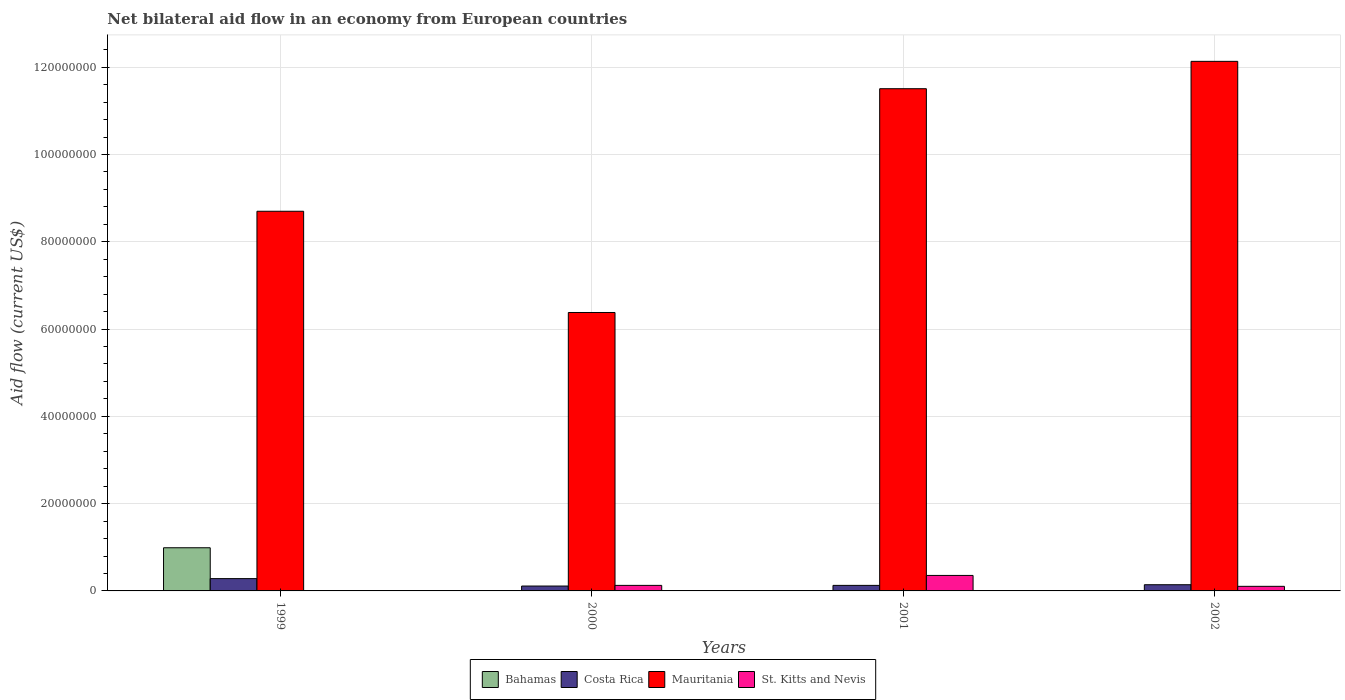How many groups of bars are there?
Make the answer very short. 4. Are the number of bars per tick equal to the number of legend labels?
Keep it short and to the point. No. How many bars are there on the 4th tick from the right?
Give a very brief answer. 3. What is the label of the 3rd group of bars from the left?
Your answer should be very brief. 2001. In how many cases, is the number of bars for a given year not equal to the number of legend labels?
Offer a terse response. 4. What is the net bilateral aid flow in St. Kitts and Nevis in 1999?
Keep it short and to the point. 0. Across all years, what is the maximum net bilateral aid flow in Costa Rica?
Keep it short and to the point. 2.82e+06. In which year was the net bilateral aid flow in Mauritania maximum?
Make the answer very short. 2002. What is the total net bilateral aid flow in Costa Rica in the graph?
Make the answer very short. 6.63e+06. What is the difference between the net bilateral aid flow in Costa Rica in 1999 and that in 2000?
Provide a succinct answer. 1.70e+06. What is the difference between the net bilateral aid flow in St. Kitts and Nevis in 2001 and the net bilateral aid flow in Costa Rica in 1999?
Provide a short and direct response. 7.30e+05. What is the average net bilateral aid flow in Mauritania per year?
Ensure brevity in your answer.  9.68e+07. In the year 1999, what is the difference between the net bilateral aid flow in Costa Rica and net bilateral aid flow in Bahamas?
Offer a very short reply. -7.07e+06. In how many years, is the net bilateral aid flow in Mauritania greater than 44000000 US$?
Provide a succinct answer. 4. What is the ratio of the net bilateral aid flow in Mauritania in 2000 to that in 2002?
Offer a terse response. 0.53. Is the net bilateral aid flow in Mauritania in 1999 less than that in 2002?
Give a very brief answer. Yes. What is the difference between the highest and the second highest net bilateral aid flow in Mauritania?
Offer a very short reply. 6.27e+06. What is the difference between the highest and the lowest net bilateral aid flow in Mauritania?
Provide a short and direct response. 5.76e+07. In how many years, is the net bilateral aid flow in St. Kitts and Nevis greater than the average net bilateral aid flow in St. Kitts and Nevis taken over all years?
Provide a succinct answer. 1. How many years are there in the graph?
Provide a succinct answer. 4. What is the difference between two consecutive major ticks on the Y-axis?
Your answer should be very brief. 2.00e+07. Are the values on the major ticks of Y-axis written in scientific E-notation?
Make the answer very short. No. Does the graph contain grids?
Your answer should be very brief. Yes. Where does the legend appear in the graph?
Keep it short and to the point. Bottom center. How are the legend labels stacked?
Provide a succinct answer. Horizontal. What is the title of the graph?
Keep it short and to the point. Net bilateral aid flow in an economy from European countries. What is the label or title of the Y-axis?
Offer a terse response. Aid flow (current US$). What is the Aid flow (current US$) of Bahamas in 1999?
Keep it short and to the point. 9.89e+06. What is the Aid flow (current US$) in Costa Rica in 1999?
Provide a succinct answer. 2.82e+06. What is the Aid flow (current US$) of Mauritania in 1999?
Keep it short and to the point. 8.70e+07. What is the Aid flow (current US$) in St. Kitts and Nevis in 1999?
Provide a succinct answer. 0. What is the Aid flow (current US$) of Costa Rica in 2000?
Keep it short and to the point. 1.12e+06. What is the Aid flow (current US$) in Mauritania in 2000?
Give a very brief answer. 6.38e+07. What is the Aid flow (current US$) of St. Kitts and Nevis in 2000?
Your answer should be very brief. 1.27e+06. What is the Aid flow (current US$) of Costa Rica in 2001?
Give a very brief answer. 1.27e+06. What is the Aid flow (current US$) in Mauritania in 2001?
Make the answer very short. 1.15e+08. What is the Aid flow (current US$) of St. Kitts and Nevis in 2001?
Provide a succinct answer. 3.55e+06. What is the Aid flow (current US$) of Bahamas in 2002?
Make the answer very short. 0. What is the Aid flow (current US$) in Costa Rica in 2002?
Provide a succinct answer. 1.42e+06. What is the Aid flow (current US$) of Mauritania in 2002?
Keep it short and to the point. 1.21e+08. What is the Aid flow (current US$) in St. Kitts and Nevis in 2002?
Your response must be concise. 1.05e+06. Across all years, what is the maximum Aid flow (current US$) of Bahamas?
Your answer should be compact. 9.89e+06. Across all years, what is the maximum Aid flow (current US$) in Costa Rica?
Offer a very short reply. 2.82e+06. Across all years, what is the maximum Aid flow (current US$) in Mauritania?
Provide a succinct answer. 1.21e+08. Across all years, what is the maximum Aid flow (current US$) in St. Kitts and Nevis?
Your answer should be compact. 3.55e+06. Across all years, what is the minimum Aid flow (current US$) in Bahamas?
Offer a terse response. 0. Across all years, what is the minimum Aid flow (current US$) in Costa Rica?
Give a very brief answer. 1.12e+06. Across all years, what is the minimum Aid flow (current US$) in Mauritania?
Keep it short and to the point. 6.38e+07. Across all years, what is the minimum Aid flow (current US$) of St. Kitts and Nevis?
Offer a very short reply. 0. What is the total Aid flow (current US$) in Bahamas in the graph?
Provide a short and direct response. 9.89e+06. What is the total Aid flow (current US$) in Costa Rica in the graph?
Ensure brevity in your answer.  6.63e+06. What is the total Aid flow (current US$) of Mauritania in the graph?
Keep it short and to the point. 3.87e+08. What is the total Aid flow (current US$) in St. Kitts and Nevis in the graph?
Offer a terse response. 5.87e+06. What is the difference between the Aid flow (current US$) of Costa Rica in 1999 and that in 2000?
Make the answer very short. 1.70e+06. What is the difference between the Aid flow (current US$) of Mauritania in 1999 and that in 2000?
Provide a succinct answer. 2.32e+07. What is the difference between the Aid flow (current US$) of Costa Rica in 1999 and that in 2001?
Ensure brevity in your answer.  1.55e+06. What is the difference between the Aid flow (current US$) in Mauritania in 1999 and that in 2001?
Make the answer very short. -2.81e+07. What is the difference between the Aid flow (current US$) of Costa Rica in 1999 and that in 2002?
Provide a succinct answer. 1.40e+06. What is the difference between the Aid flow (current US$) of Mauritania in 1999 and that in 2002?
Your answer should be very brief. -3.44e+07. What is the difference between the Aid flow (current US$) of Mauritania in 2000 and that in 2001?
Your answer should be very brief. -5.13e+07. What is the difference between the Aid flow (current US$) of St. Kitts and Nevis in 2000 and that in 2001?
Provide a short and direct response. -2.28e+06. What is the difference between the Aid flow (current US$) in Mauritania in 2000 and that in 2002?
Provide a short and direct response. -5.76e+07. What is the difference between the Aid flow (current US$) in Costa Rica in 2001 and that in 2002?
Your answer should be compact. -1.50e+05. What is the difference between the Aid flow (current US$) of Mauritania in 2001 and that in 2002?
Ensure brevity in your answer.  -6.27e+06. What is the difference between the Aid flow (current US$) of St. Kitts and Nevis in 2001 and that in 2002?
Ensure brevity in your answer.  2.50e+06. What is the difference between the Aid flow (current US$) in Bahamas in 1999 and the Aid flow (current US$) in Costa Rica in 2000?
Offer a very short reply. 8.77e+06. What is the difference between the Aid flow (current US$) in Bahamas in 1999 and the Aid flow (current US$) in Mauritania in 2000?
Give a very brief answer. -5.39e+07. What is the difference between the Aid flow (current US$) in Bahamas in 1999 and the Aid flow (current US$) in St. Kitts and Nevis in 2000?
Your answer should be compact. 8.62e+06. What is the difference between the Aid flow (current US$) in Costa Rica in 1999 and the Aid flow (current US$) in Mauritania in 2000?
Make the answer very short. -6.10e+07. What is the difference between the Aid flow (current US$) in Costa Rica in 1999 and the Aid flow (current US$) in St. Kitts and Nevis in 2000?
Ensure brevity in your answer.  1.55e+06. What is the difference between the Aid flow (current US$) of Mauritania in 1999 and the Aid flow (current US$) of St. Kitts and Nevis in 2000?
Offer a terse response. 8.57e+07. What is the difference between the Aid flow (current US$) of Bahamas in 1999 and the Aid flow (current US$) of Costa Rica in 2001?
Your answer should be very brief. 8.62e+06. What is the difference between the Aid flow (current US$) of Bahamas in 1999 and the Aid flow (current US$) of Mauritania in 2001?
Ensure brevity in your answer.  -1.05e+08. What is the difference between the Aid flow (current US$) in Bahamas in 1999 and the Aid flow (current US$) in St. Kitts and Nevis in 2001?
Offer a terse response. 6.34e+06. What is the difference between the Aid flow (current US$) of Costa Rica in 1999 and the Aid flow (current US$) of Mauritania in 2001?
Keep it short and to the point. -1.12e+08. What is the difference between the Aid flow (current US$) in Costa Rica in 1999 and the Aid flow (current US$) in St. Kitts and Nevis in 2001?
Keep it short and to the point. -7.30e+05. What is the difference between the Aid flow (current US$) in Mauritania in 1999 and the Aid flow (current US$) in St. Kitts and Nevis in 2001?
Your response must be concise. 8.34e+07. What is the difference between the Aid flow (current US$) in Bahamas in 1999 and the Aid flow (current US$) in Costa Rica in 2002?
Provide a succinct answer. 8.47e+06. What is the difference between the Aid flow (current US$) in Bahamas in 1999 and the Aid flow (current US$) in Mauritania in 2002?
Offer a terse response. -1.11e+08. What is the difference between the Aid flow (current US$) of Bahamas in 1999 and the Aid flow (current US$) of St. Kitts and Nevis in 2002?
Provide a succinct answer. 8.84e+06. What is the difference between the Aid flow (current US$) of Costa Rica in 1999 and the Aid flow (current US$) of Mauritania in 2002?
Provide a succinct answer. -1.19e+08. What is the difference between the Aid flow (current US$) in Costa Rica in 1999 and the Aid flow (current US$) in St. Kitts and Nevis in 2002?
Provide a succinct answer. 1.77e+06. What is the difference between the Aid flow (current US$) in Mauritania in 1999 and the Aid flow (current US$) in St. Kitts and Nevis in 2002?
Keep it short and to the point. 8.60e+07. What is the difference between the Aid flow (current US$) in Costa Rica in 2000 and the Aid flow (current US$) in Mauritania in 2001?
Provide a short and direct response. -1.14e+08. What is the difference between the Aid flow (current US$) in Costa Rica in 2000 and the Aid flow (current US$) in St. Kitts and Nevis in 2001?
Provide a short and direct response. -2.43e+06. What is the difference between the Aid flow (current US$) in Mauritania in 2000 and the Aid flow (current US$) in St. Kitts and Nevis in 2001?
Provide a short and direct response. 6.02e+07. What is the difference between the Aid flow (current US$) in Costa Rica in 2000 and the Aid flow (current US$) in Mauritania in 2002?
Provide a short and direct response. -1.20e+08. What is the difference between the Aid flow (current US$) in Mauritania in 2000 and the Aid flow (current US$) in St. Kitts and Nevis in 2002?
Your answer should be very brief. 6.28e+07. What is the difference between the Aid flow (current US$) in Costa Rica in 2001 and the Aid flow (current US$) in Mauritania in 2002?
Ensure brevity in your answer.  -1.20e+08. What is the difference between the Aid flow (current US$) of Mauritania in 2001 and the Aid flow (current US$) of St. Kitts and Nevis in 2002?
Give a very brief answer. 1.14e+08. What is the average Aid flow (current US$) in Bahamas per year?
Your answer should be very brief. 2.47e+06. What is the average Aid flow (current US$) in Costa Rica per year?
Offer a terse response. 1.66e+06. What is the average Aid flow (current US$) of Mauritania per year?
Give a very brief answer. 9.68e+07. What is the average Aid flow (current US$) in St. Kitts and Nevis per year?
Your answer should be compact. 1.47e+06. In the year 1999, what is the difference between the Aid flow (current US$) of Bahamas and Aid flow (current US$) of Costa Rica?
Give a very brief answer. 7.07e+06. In the year 1999, what is the difference between the Aid flow (current US$) of Bahamas and Aid flow (current US$) of Mauritania?
Your answer should be very brief. -7.71e+07. In the year 1999, what is the difference between the Aid flow (current US$) of Costa Rica and Aid flow (current US$) of Mauritania?
Ensure brevity in your answer.  -8.42e+07. In the year 2000, what is the difference between the Aid flow (current US$) of Costa Rica and Aid flow (current US$) of Mauritania?
Keep it short and to the point. -6.27e+07. In the year 2000, what is the difference between the Aid flow (current US$) in Mauritania and Aid flow (current US$) in St. Kitts and Nevis?
Ensure brevity in your answer.  6.25e+07. In the year 2001, what is the difference between the Aid flow (current US$) of Costa Rica and Aid flow (current US$) of Mauritania?
Ensure brevity in your answer.  -1.14e+08. In the year 2001, what is the difference between the Aid flow (current US$) in Costa Rica and Aid flow (current US$) in St. Kitts and Nevis?
Your answer should be compact. -2.28e+06. In the year 2001, what is the difference between the Aid flow (current US$) in Mauritania and Aid flow (current US$) in St. Kitts and Nevis?
Ensure brevity in your answer.  1.12e+08. In the year 2002, what is the difference between the Aid flow (current US$) in Costa Rica and Aid flow (current US$) in Mauritania?
Your response must be concise. -1.20e+08. In the year 2002, what is the difference between the Aid flow (current US$) of Costa Rica and Aid flow (current US$) of St. Kitts and Nevis?
Provide a short and direct response. 3.70e+05. In the year 2002, what is the difference between the Aid flow (current US$) in Mauritania and Aid flow (current US$) in St. Kitts and Nevis?
Keep it short and to the point. 1.20e+08. What is the ratio of the Aid flow (current US$) of Costa Rica in 1999 to that in 2000?
Keep it short and to the point. 2.52. What is the ratio of the Aid flow (current US$) of Mauritania in 1999 to that in 2000?
Your response must be concise. 1.36. What is the ratio of the Aid flow (current US$) of Costa Rica in 1999 to that in 2001?
Give a very brief answer. 2.22. What is the ratio of the Aid flow (current US$) in Mauritania in 1999 to that in 2001?
Your answer should be compact. 0.76. What is the ratio of the Aid flow (current US$) of Costa Rica in 1999 to that in 2002?
Your response must be concise. 1.99. What is the ratio of the Aid flow (current US$) in Mauritania in 1999 to that in 2002?
Offer a terse response. 0.72. What is the ratio of the Aid flow (current US$) of Costa Rica in 2000 to that in 2001?
Offer a terse response. 0.88. What is the ratio of the Aid flow (current US$) of Mauritania in 2000 to that in 2001?
Ensure brevity in your answer.  0.55. What is the ratio of the Aid flow (current US$) of St. Kitts and Nevis in 2000 to that in 2001?
Keep it short and to the point. 0.36. What is the ratio of the Aid flow (current US$) in Costa Rica in 2000 to that in 2002?
Offer a very short reply. 0.79. What is the ratio of the Aid flow (current US$) of Mauritania in 2000 to that in 2002?
Give a very brief answer. 0.53. What is the ratio of the Aid flow (current US$) in St. Kitts and Nevis in 2000 to that in 2002?
Ensure brevity in your answer.  1.21. What is the ratio of the Aid flow (current US$) in Costa Rica in 2001 to that in 2002?
Give a very brief answer. 0.89. What is the ratio of the Aid flow (current US$) in Mauritania in 2001 to that in 2002?
Your answer should be very brief. 0.95. What is the ratio of the Aid flow (current US$) in St. Kitts and Nevis in 2001 to that in 2002?
Your answer should be compact. 3.38. What is the difference between the highest and the second highest Aid flow (current US$) in Costa Rica?
Keep it short and to the point. 1.40e+06. What is the difference between the highest and the second highest Aid flow (current US$) in Mauritania?
Give a very brief answer. 6.27e+06. What is the difference between the highest and the second highest Aid flow (current US$) in St. Kitts and Nevis?
Provide a succinct answer. 2.28e+06. What is the difference between the highest and the lowest Aid flow (current US$) in Bahamas?
Offer a very short reply. 9.89e+06. What is the difference between the highest and the lowest Aid flow (current US$) in Costa Rica?
Make the answer very short. 1.70e+06. What is the difference between the highest and the lowest Aid flow (current US$) of Mauritania?
Give a very brief answer. 5.76e+07. What is the difference between the highest and the lowest Aid flow (current US$) in St. Kitts and Nevis?
Your answer should be very brief. 3.55e+06. 